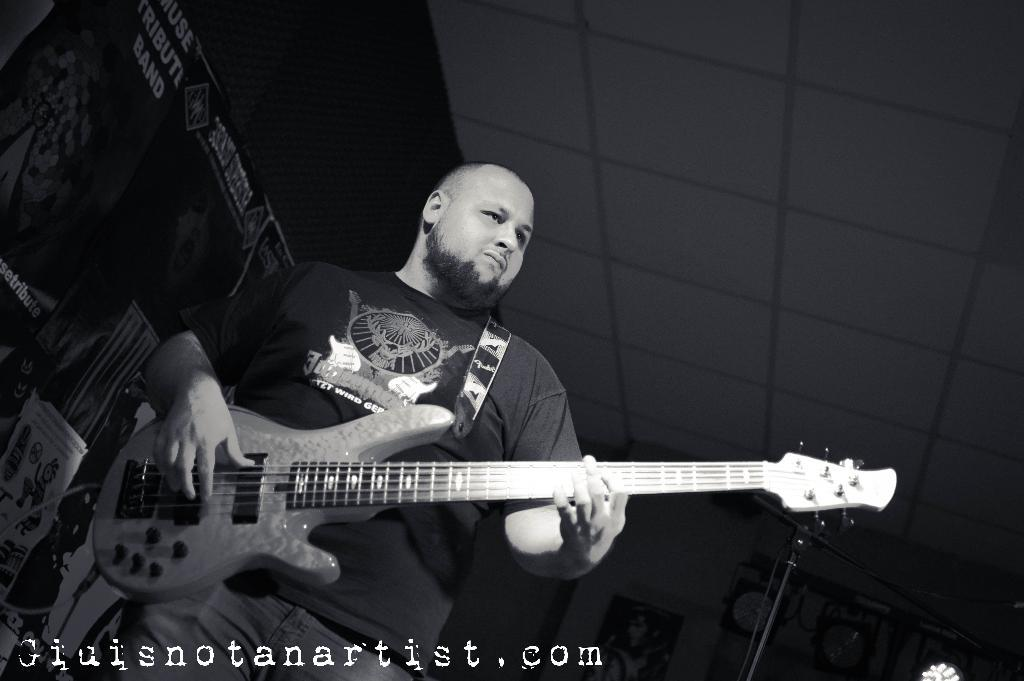What is the color scheme of the image? The image is black and white. What is the man in the image doing? The man is playing a guitar. What can be seen in the background of the image? There are posters in the background of the image. What type of star can be seen in the image? There is no star visible in the image, as it is a black and white photograph of a man playing a guitar with posters in the background. 